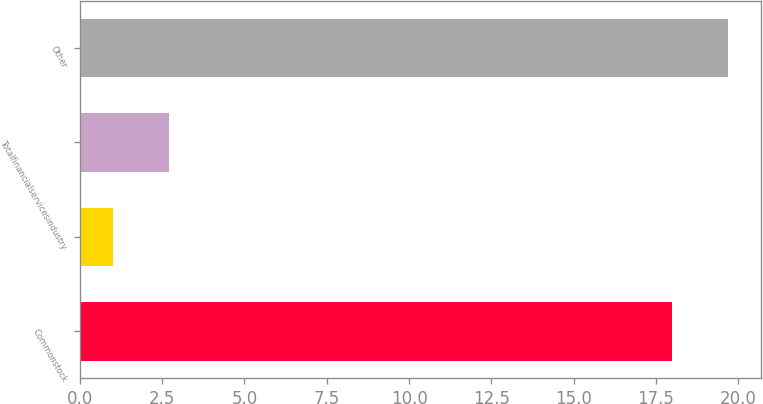Convert chart to OTSL. <chart><loc_0><loc_0><loc_500><loc_500><bar_chart><fcel>Commonstock<fcel>Unnamed: 1<fcel>Totalfinancialservicesindustry<fcel>Other<nl><fcel>18<fcel>1<fcel>2.7<fcel>19.7<nl></chart> 